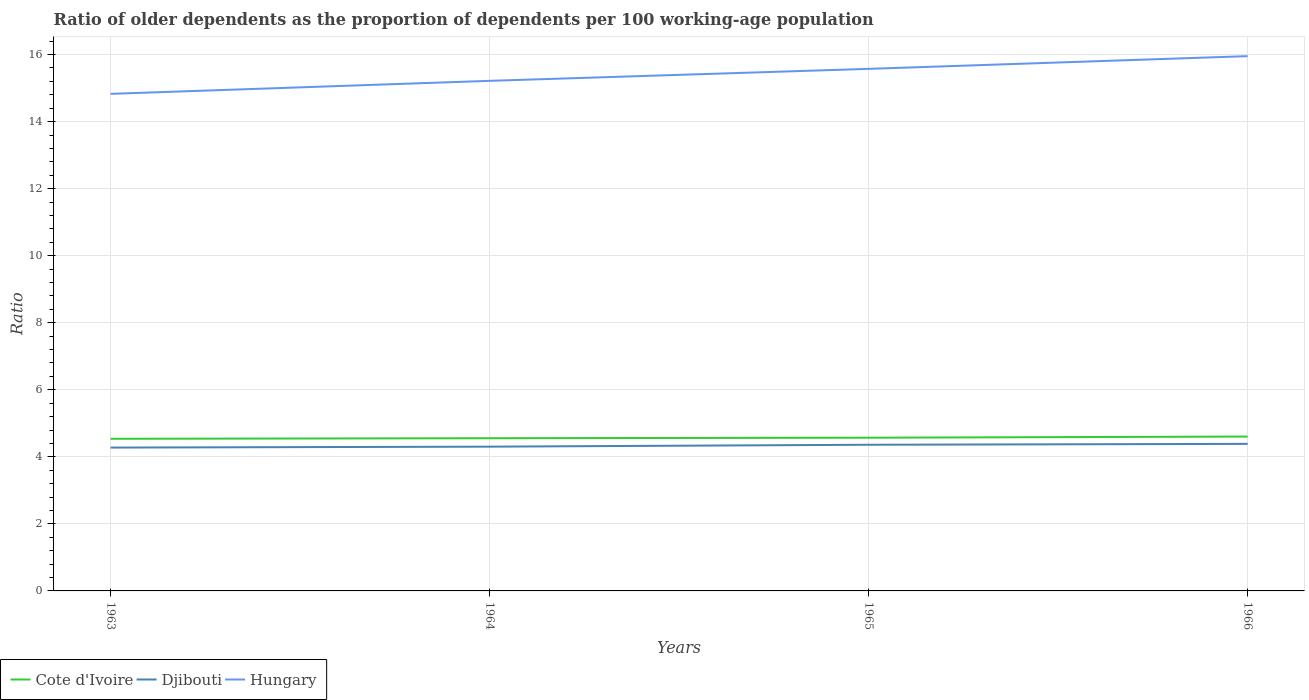How many different coloured lines are there?
Offer a terse response. 3. Across all years, what is the maximum age dependency ratio(old) in Hungary?
Provide a short and direct response. 14.83. What is the total age dependency ratio(old) in Djibouti in the graph?
Give a very brief answer. -0.03. What is the difference between the highest and the second highest age dependency ratio(old) in Cote d'Ivoire?
Ensure brevity in your answer.  0.07. What is the difference between the highest and the lowest age dependency ratio(old) in Hungary?
Offer a terse response. 2. How many lines are there?
Your response must be concise. 3. How many years are there in the graph?
Provide a succinct answer. 4. Does the graph contain grids?
Provide a short and direct response. Yes. What is the title of the graph?
Your answer should be compact. Ratio of older dependents as the proportion of dependents per 100 working-age population. Does "Indonesia" appear as one of the legend labels in the graph?
Make the answer very short. No. What is the label or title of the Y-axis?
Provide a succinct answer. Ratio. What is the Ratio in Cote d'Ivoire in 1963?
Your answer should be very brief. 4.54. What is the Ratio of Djibouti in 1963?
Provide a short and direct response. 4.28. What is the Ratio of Hungary in 1963?
Your answer should be very brief. 14.83. What is the Ratio in Cote d'Ivoire in 1964?
Offer a very short reply. 4.56. What is the Ratio in Djibouti in 1964?
Make the answer very short. 4.3. What is the Ratio of Hungary in 1964?
Your answer should be compact. 15.22. What is the Ratio of Cote d'Ivoire in 1965?
Provide a short and direct response. 4.57. What is the Ratio in Djibouti in 1965?
Offer a terse response. 4.36. What is the Ratio of Hungary in 1965?
Your response must be concise. 15.57. What is the Ratio of Cote d'Ivoire in 1966?
Make the answer very short. 4.61. What is the Ratio in Djibouti in 1966?
Your answer should be compact. 4.39. What is the Ratio of Hungary in 1966?
Make the answer very short. 15.95. Across all years, what is the maximum Ratio in Cote d'Ivoire?
Make the answer very short. 4.61. Across all years, what is the maximum Ratio in Djibouti?
Your answer should be very brief. 4.39. Across all years, what is the maximum Ratio in Hungary?
Make the answer very short. 15.95. Across all years, what is the minimum Ratio in Cote d'Ivoire?
Offer a very short reply. 4.54. Across all years, what is the minimum Ratio in Djibouti?
Your answer should be very brief. 4.28. Across all years, what is the minimum Ratio of Hungary?
Offer a very short reply. 14.83. What is the total Ratio of Cote d'Ivoire in the graph?
Provide a short and direct response. 18.27. What is the total Ratio in Djibouti in the graph?
Give a very brief answer. 17.33. What is the total Ratio in Hungary in the graph?
Offer a terse response. 61.57. What is the difference between the Ratio in Cote d'Ivoire in 1963 and that in 1964?
Ensure brevity in your answer.  -0.02. What is the difference between the Ratio of Djibouti in 1963 and that in 1964?
Provide a succinct answer. -0.03. What is the difference between the Ratio in Hungary in 1963 and that in 1964?
Your answer should be very brief. -0.39. What is the difference between the Ratio of Cote d'Ivoire in 1963 and that in 1965?
Provide a short and direct response. -0.03. What is the difference between the Ratio of Djibouti in 1963 and that in 1965?
Make the answer very short. -0.08. What is the difference between the Ratio of Hungary in 1963 and that in 1965?
Offer a very short reply. -0.75. What is the difference between the Ratio in Cote d'Ivoire in 1963 and that in 1966?
Provide a short and direct response. -0.07. What is the difference between the Ratio in Djibouti in 1963 and that in 1966?
Offer a terse response. -0.11. What is the difference between the Ratio of Hungary in 1963 and that in 1966?
Provide a succinct answer. -1.12. What is the difference between the Ratio of Cote d'Ivoire in 1964 and that in 1965?
Make the answer very short. -0.02. What is the difference between the Ratio of Djibouti in 1964 and that in 1965?
Provide a succinct answer. -0.06. What is the difference between the Ratio in Hungary in 1964 and that in 1965?
Provide a succinct answer. -0.36. What is the difference between the Ratio of Cote d'Ivoire in 1964 and that in 1966?
Ensure brevity in your answer.  -0.05. What is the difference between the Ratio of Djibouti in 1964 and that in 1966?
Keep it short and to the point. -0.08. What is the difference between the Ratio in Hungary in 1964 and that in 1966?
Your answer should be compact. -0.74. What is the difference between the Ratio in Cote d'Ivoire in 1965 and that in 1966?
Your answer should be very brief. -0.03. What is the difference between the Ratio in Djibouti in 1965 and that in 1966?
Your response must be concise. -0.03. What is the difference between the Ratio in Hungary in 1965 and that in 1966?
Give a very brief answer. -0.38. What is the difference between the Ratio in Cote d'Ivoire in 1963 and the Ratio in Djibouti in 1964?
Provide a short and direct response. 0.23. What is the difference between the Ratio in Cote d'Ivoire in 1963 and the Ratio in Hungary in 1964?
Your response must be concise. -10.68. What is the difference between the Ratio in Djibouti in 1963 and the Ratio in Hungary in 1964?
Make the answer very short. -10.94. What is the difference between the Ratio in Cote d'Ivoire in 1963 and the Ratio in Djibouti in 1965?
Make the answer very short. 0.18. What is the difference between the Ratio in Cote d'Ivoire in 1963 and the Ratio in Hungary in 1965?
Provide a succinct answer. -11.04. What is the difference between the Ratio of Djibouti in 1963 and the Ratio of Hungary in 1965?
Offer a very short reply. -11.3. What is the difference between the Ratio of Cote d'Ivoire in 1963 and the Ratio of Djibouti in 1966?
Provide a short and direct response. 0.15. What is the difference between the Ratio of Cote d'Ivoire in 1963 and the Ratio of Hungary in 1966?
Your response must be concise. -11.41. What is the difference between the Ratio in Djibouti in 1963 and the Ratio in Hungary in 1966?
Your answer should be compact. -11.68. What is the difference between the Ratio in Cote d'Ivoire in 1964 and the Ratio in Djibouti in 1965?
Your answer should be compact. 0.19. What is the difference between the Ratio in Cote d'Ivoire in 1964 and the Ratio in Hungary in 1965?
Give a very brief answer. -11.02. What is the difference between the Ratio of Djibouti in 1964 and the Ratio of Hungary in 1965?
Give a very brief answer. -11.27. What is the difference between the Ratio of Cote d'Ivoire in 1964 and the Ratio of Djibouti in 1966?
Ensure brevity in your answer.  0.17. What is the difference between the Ratio of Cote d'Ivoire in 1964 and the Ratio of Hungary in 1966?
Your answer should be very brief. -11.4. What is the difference between the Ratio of Djibouti in 1964 and the Ratio of Hungary in 1966?
Keep it short and to the point. -11.65. What is the difference between the Ratio of Cote d'Ivoire in 1965 and the Ratio of Djibouti in 1966?
Offer a terse response. 0.18. What is the difference between the Ratio in Cote d'Ivoire in 1965 and the Ratio in Hungary in 1966?
Your answer should be compact. -11.38. What is the difference between the Ratio in Djibouti in 1965 and the Ratio in Hungary in 1966?
Make the answer very short. -11.59. What is the average Ratio in Cote d'Ivoire per year?
Give a very brief answer. 4.57. What is the average Ratio of Djibouti per year?
Keep it short and to the point. 4.33. What is the average Ratio in Hungary per year?
Your answer should be compact. 15.39. In the year 1963, what is the difference between the Ratio of Cote d'Ivoire and Ratio of Djibouti?
Give a very brief answer. 0.26. In the year 1963, what is the difference between the Ratio in Cote d'Ivoire and Ratio in Hungary?
Keep it short and to the point. -10.29. In the year 1963, what is the difference between the Ratio in Djibouti and Ratio in Hungary?
Give a very brief answer. -10.55. In the year 1964, what is the difference between the Ratio of Cote d'Ivoire and Ratio of Djibouti?
Offer a very short reply. 0.25. In the year 1964, what is the difference between the Ratio in Cote d'Ivoire and Ratio in Hungary?
Ensure brevity in your answer.  -10.66. In the year 1964, what is the difference between the Ratio of Djibouti and Ratio of Hungary?
Offer a very short reply. -10.91. In the year 1965, what is the difference between the Ratio in Cote d'Ivoire and Ratio in Djibouti?
Your response must be concise. 0.21. In the year 1965, what is the difference between the Ratio of Cote d'Ivoire and Ratio of Hungary?
Offer a very short reply. -11. In the year 1965, what is the difference between the Ratio of Djibouti and Ratio of Hungary?
Your answer should be compact. -11.21. In the year 1966, what is the difference between the Ratio of Cote d'Ivoire and Ratio of Djibouti?
Your response must be concise. 0.22. In the year 1966, what is the difference between the Ratio in Cote d'Ivoire and Ratio in Hungary?
Your answer should be compact. -11.35. In the year 1966, what is the difference between the Ratio of Djibouti and Ratio of Hungary?
Make the answer very short. -11.57. What is the ratio of the Ratio in Hungary in 1963 to that in 1964?
Provide a succinct answer. 0.97. What is the ratio of the Ratio of Djibouti in 1963 to that in 1965?
Give a very brief answer. 0.98. What is the ratio of the Ratio of Hungary in 1963 to that in 1965?
Provide a succinct answer. 0.95. What is the ratio of the Ratio in Cote d'Ivoire in 1963 to that in 1966?
Keep it short and to the point. 0.99. What is the ratio of the Ratio in Djibouti in 1963 to that in 1966?
Make the answer very short. 0.97. What is the ratio of the Ratio in Hungary in 1963 to that in 1966?
Your answer should be compact. 0.93. What is the ratio of the Ratio of Djibouti in 1964 to that in 1965?
Keep it short and to the point. 0.99. What is the ratio of the Ratio of Djibouti in 1964 to that in 1966?
Make the answer very short. 0.98. What is the ratio of the Ratio of Hungary in 1964 to that in 1966?
Make the answer very short. 0.95. What is the ratio of the Ratio of Cote d'Ivoire in 1965 to that in 1966?
Keep it short and to the point. 0.99. What is the ratio of the Ratio of Hungary in 1965 to that in 1966?
Your response must be concise. 0.98. What is the difference between the highest and the second highest Ratio in Cote d'Ivoire?
Offer a very short reply. 0.03. What is the difference between the highest and the second highest Ratio of Djibouti?
Make the answer very short. 0.03. What is the difference between the highest and the second highest Ratio of Hungary?
Your response must be concise. 0.38. What is the difference between the highest and the lowest Ratio of Cote d'Ivoire?
Your answer should be compact. 0.07. What is the difference between the highest and the lowest Ratio of Djibouti?
Ensure brevity in your answer.  0.11. What is the difference between the highest and the lowest Ratio of Hungary?
Your response must be concise. 1.12. 